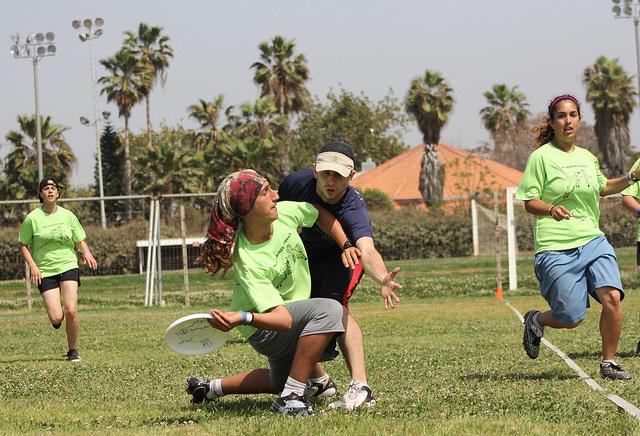Is a female catching the frisbee?
Quick response, please. No. Which hand has a Frisbee?
Concise answer only. Right. How many people in this photo are on the green team?
Short answer required. 4. Is the girl trying to grab the frisbee?
Be succinct. No. What are they playing?
Write a very short answer. Frisbee. 